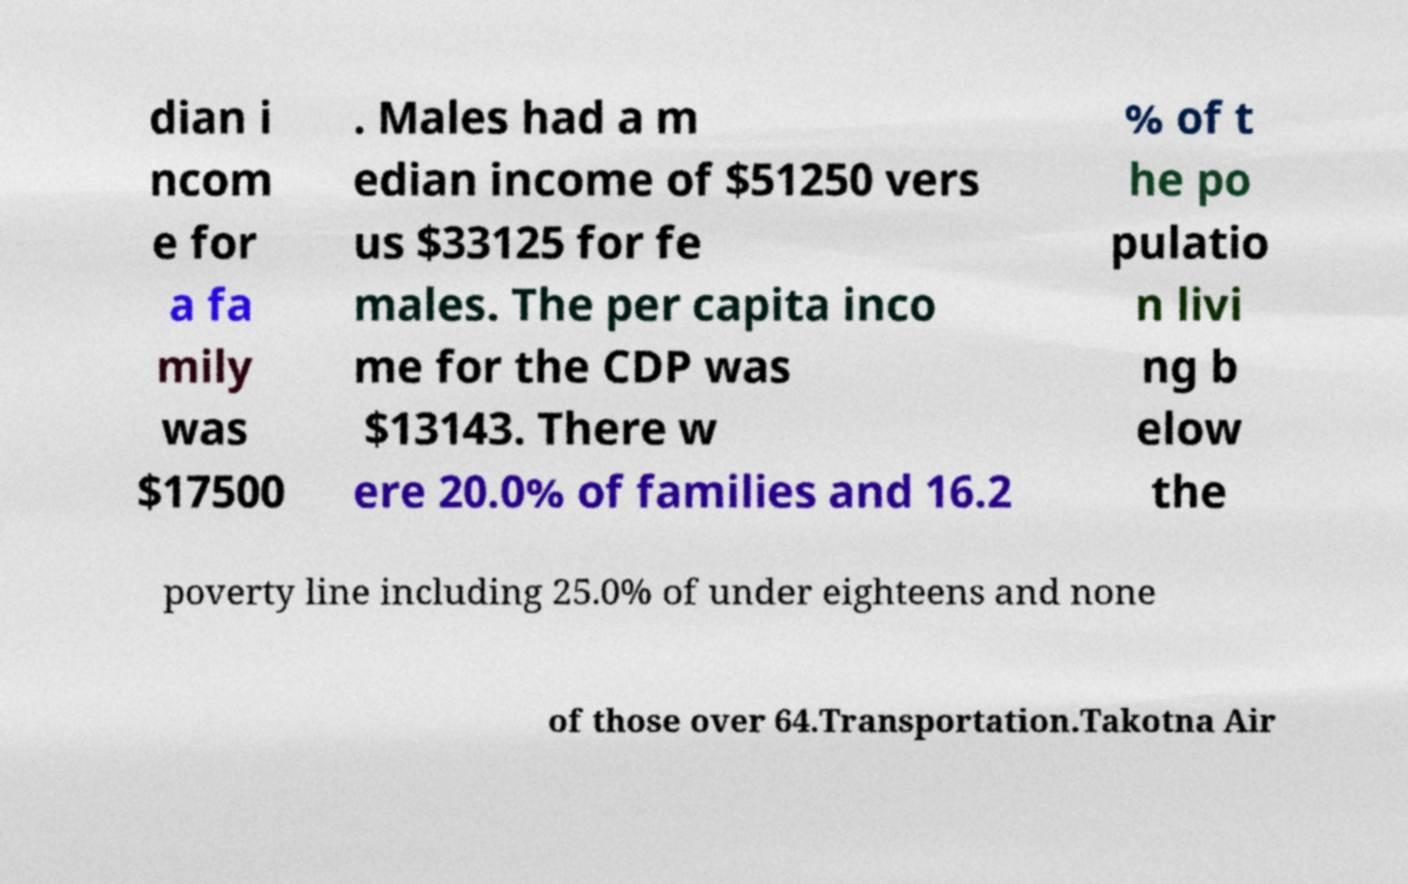There's text embedded in this image that I need extracted. Can you transcribe it verbatim? dian i ncom e for a fa mily was $17500 . Males had a m edian income of $51250 vers us $33125 for fe males. The per capita inco me for the CDP was $13143. There w ere 20.0% of families and 16.2 % of t he po pulatio n livi ng b elow the poverty line including 25.0% of under eighteens and none of those over 64.Transportation.Takotna Air 